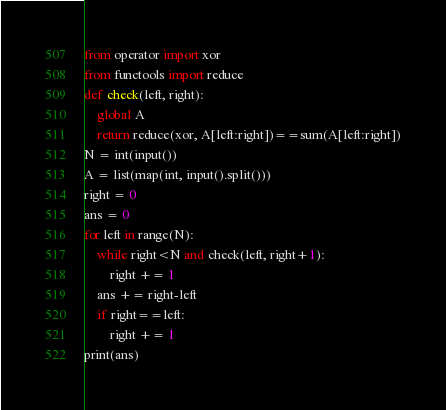<code> <loc_0><loc_0><loc_500><loc_500><_Python_>from operator import xor
from functools import reduce
def check(left, right):
    global A
    return reduce(xor, A[left:right])==sum(A[left:right])
N = int(input())
A = list(map(int, input().split()))
right = 0
ans = 0
for left in range(N):
    while right<N and check(left, right+1):
        right += 1
    ans += right-left
    if right==left:
        right += 1
print(ans)</code> 